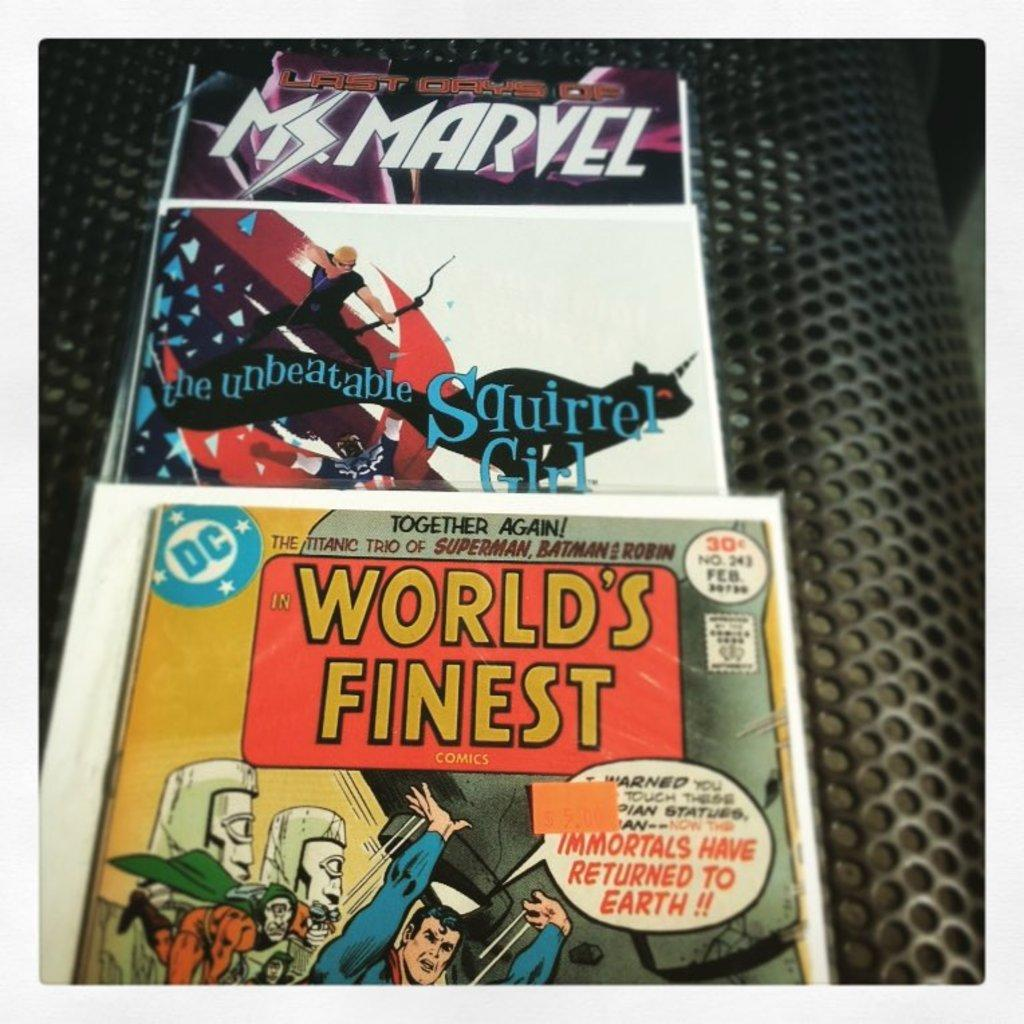Provide a one-sentence caption for the provided image. Three comic books, one of them called world's finest with Superman on the cover. 